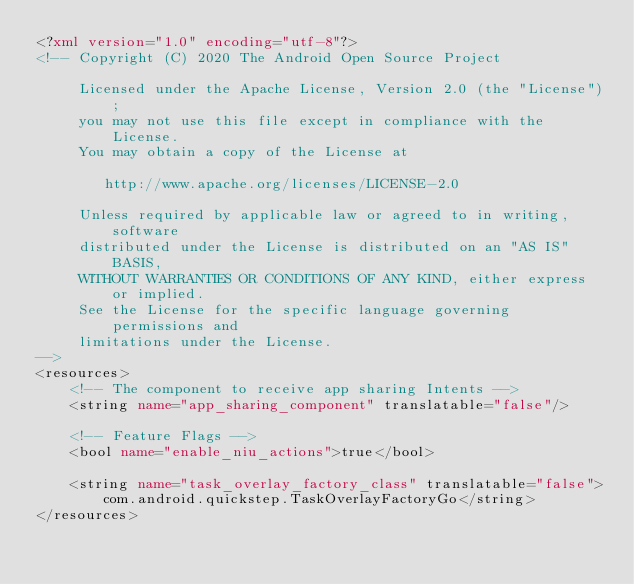<code> <loc_0><loc_0><loc_500><loc_500><_XML_><?xml version="1.0" encoding="utf-8"?>
<!-- Copyright (C) 2020 The Android Open Source Project

     Licensed under the Apache License, Version 2.0 (the "License");
     you may not use this file except in compliance with the License.
     You may obtain a copy of the License at

        http://www.apache.org/licenses/LICENSE-2.0

     Unless required by applicable law or agreed to in writing, software
     distributed under the License is distributed on an "AS IS" BASIS,
     WITHOUT WARRANTIES OR CONDITIONS OF ANY KIND, either express or implied.
     See the License for the specific language governing permissions and
     limitations under the License.
-->
<resources>
    <!-- The component to receive app sharing Intents -->
    <string name="app_sharing_component" translatable="false"/>

    <!-- Feature Flags -->
    <bool name="enable_niu_actions">true</bool>

    <string name="task_overlay_factory_class" translatable="false">com.android.quickstep.TaskOverlayFactoryGo</string>
</resources></code> 